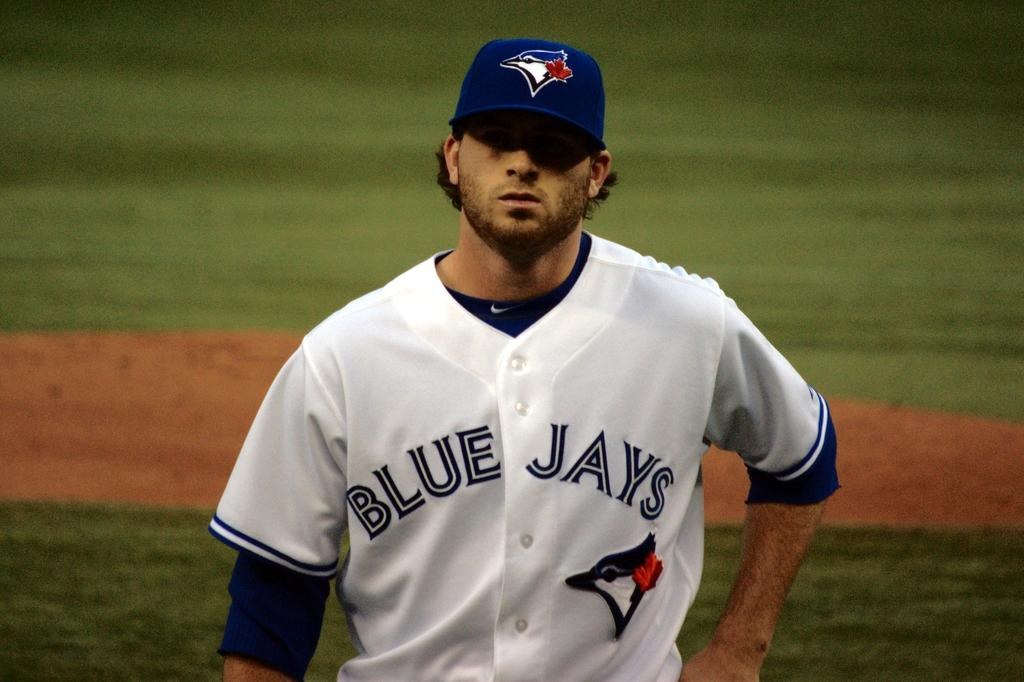<image>
Create a compact narrative representing the image presented. Toronto Blue Jays pitcher is looking into home plate. 